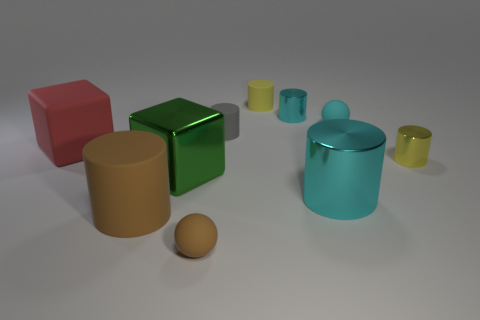There is another large thing that is the same shape as the large green metallic thing; what is its color?
Your response must be concise. Red. Is there any other thing that has the same shape as the small yellow rubber object?
Give a very brief answer. Yes. What material is the yellow cylinder that is in front of the big red object?
Make the answer very short. Metal. There is a yellow rubber object that is the same shape as the small gray rubber object; what size is it?
Offer a very short reply. Small. How many brown cylinders have the same material as the green cube?
Offer a terse response. 0. What number of matte spheres have the same color as the large shiny cylinder?
Offer a very short reply. 1. What number of things are tiny matte things in front of the big cyan thing or tiny rubber spheres right of the small brown ball?
Your response must be concise. 2. Is the number of tiny cyan things left of the yellow matte cylinder less than the number of small red metallic cylinders?
Make the answer very short. No. Is there a red matte thing of the same size as the shiny cube?
Offer a terse response. Yes. What is the color of the big shiny cylinder?
Offer a terse response. Cyan. 